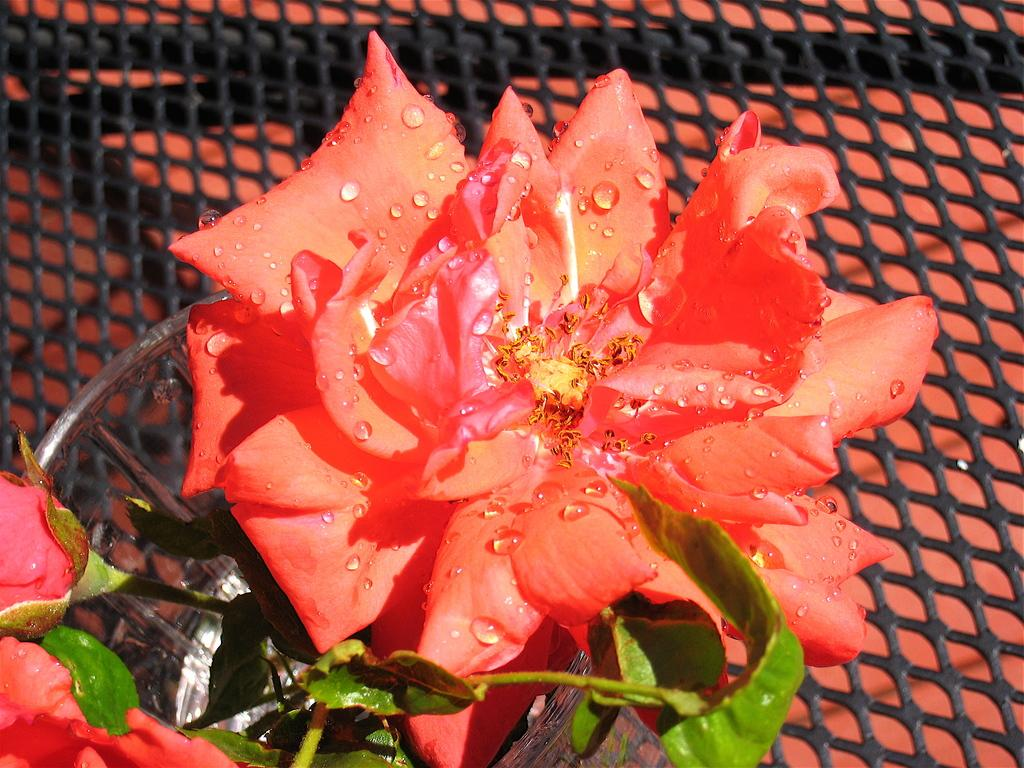What type of flower is in the image? There is a red rose flower in the image. What color are the leaves of the flower? The leaves of the flower are green. Can you describe any additional features of the flower? Yes, there are water droplets on the petals of the flower. What grade did the flower receive for its performance in the image? There is no concept of grades or performance for flowers in the image. --- Facts: 1. There is a person holding a book in the image. 2. The book has a blue cover. 3. The person is sitting on a chair. 4. There is a table next to the chair. Absurd Topics: dance, ocean, bicycle Conversation: What is the person in the image holding? The person in the image is holding a book. Can you describe the book's appearance? The book has a blue cover. Where is the person sitting in the image? The person is sitting on a chair. What is located next to the chair? There is a table next to the chair. Reasoning: Let's think step by step in order to produce the conversation. We start by identifying the main subject of the image, which is the person holding a book. Then, we describe the appearance of the book, including its blue cover. Next, we mention the person's location, which is sitting on a chair. Finally, we describe the table that is located next to the chair. Absurd Question/Answer: Can you see any ocean waves in the image? There is no ocean or waves present in the image. --- Facts: 1. There is a cat in the image. 2. The cat is sitting on a windowsill. 3. The windowsill has a red cushion. 4. There is a tree visible through the window. Absurd Topics: car, snow, piano Conversation: What animal is in the image? There is a cat in the image. Where is the cat located in the image? The cat is sitting on a windowsill. What is on the windowsill? The windowsill has a red cushion. What can be seen through the window? There is a tree visible through the window. Reasoning: Let's think step by step in order to produce the conversation. We start by identifying the main subject of the image, which is the cat. Then, we describe the cat's location, which is sitting on a windowsill. Next, we mention the red cushion on the windowsill. Finally, we describe the view through the window, which is a tree. Absurd Question/Answer: Is the cat playing a piano in the image? There is no piano present in the image, and the cat is not playing any musical instrument. 